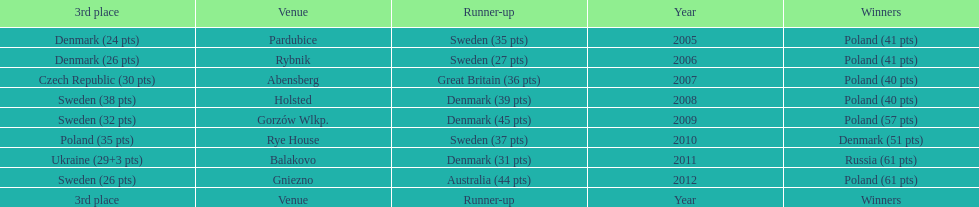What was the last year 3rd place finished with less than 25 points? 2005. 